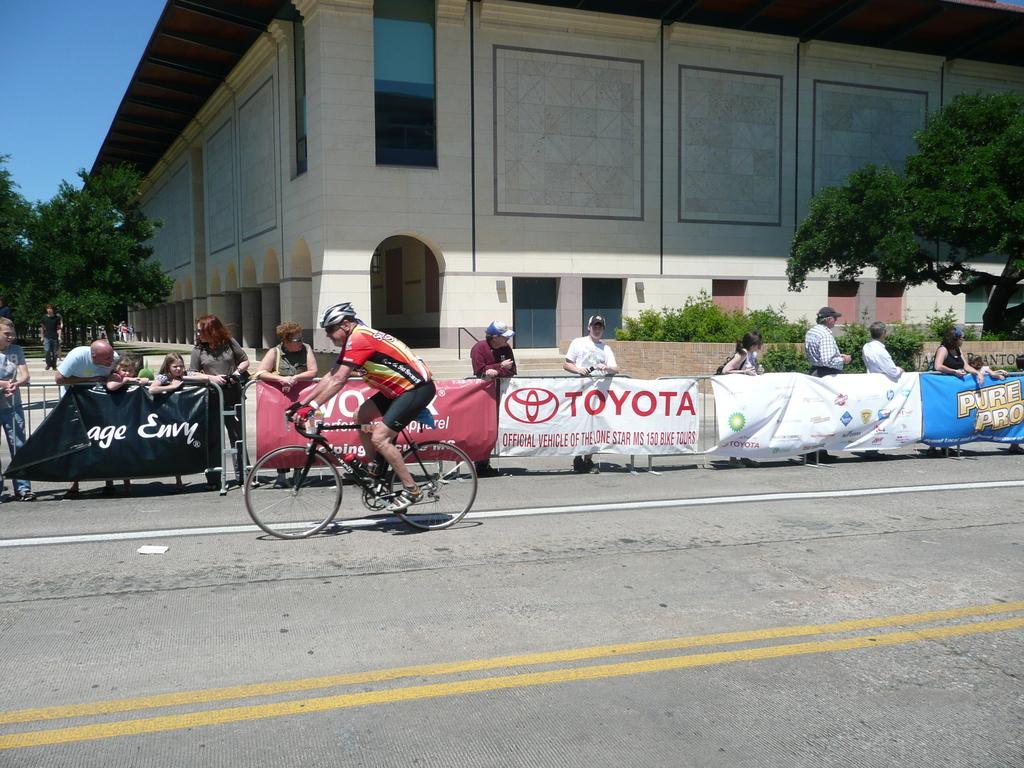In one or two sentences, can you explain what this image depicts? In this image there is a person riding bicycle, beside him there is a fence where people are standing and also there is a building and trees behind them. 